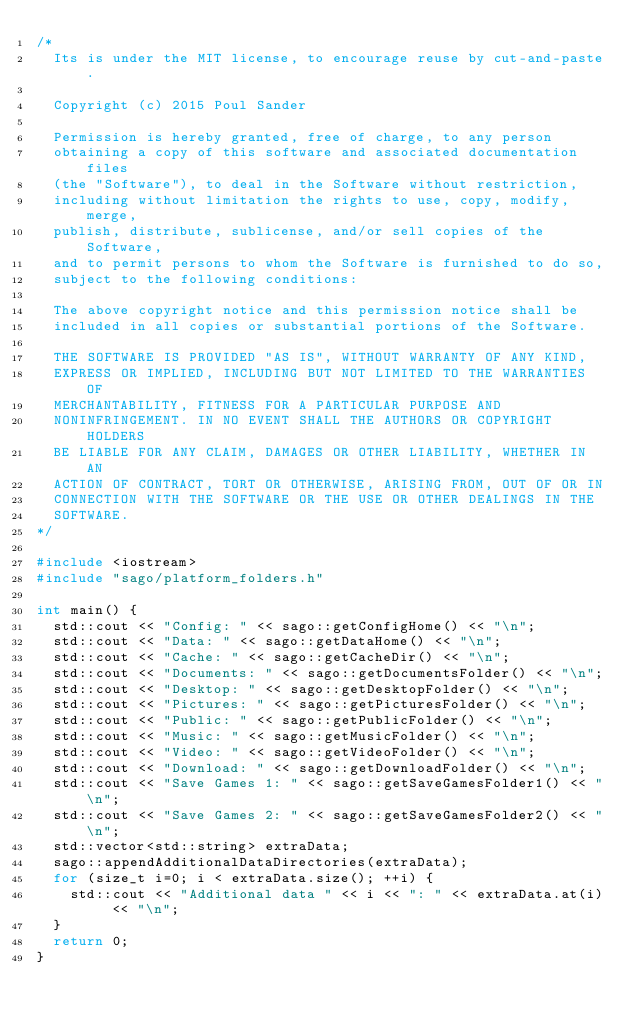Convert code to text. <code><loc_0><loc_0><loc_500><loc_500><_C++_>/*
  Its is under the MIT license, to encourage reuse by cut-and-paste.

  Copyright (c) 2015 Poul Sander

  Permission is hereby granted, free of charge, to any person
  obtaining a copy of this software and associated documentation files
  (the "Software"), to deal in the Software without restriction,
  including without limitation the rights to use, copy, modify, merge,
  publish, distribute, sublicense, and/or sell copies of the Software,
  and to permit persons to whom the Software is furnished to do so,
  subject to the following conditions:

  The above copyright notice and this permission notice shall be
  included in all copies or substantial portions of the Software.

  THE SOFTWARE IS PROVIDED "AS IS", WITHOUT WARRANTY OF ANY KIND,
  EXPRESS OR IMPLIED, INCLUDING BUT NOT LIMITED TO THE WARRANTIES OF
  MERCHANTABILITY, FITNESS FOR A PARTICULAR PURPOSE AND
  NONINFRINGEMENT. IN NO EVENT SHALL THE AUTHORS OR COPYRIGHT HOLDERS
  BE LIABLE FOR ANY CLAIM, DAMAGES OR OTHER LIABILITY, WHETHER IN AN
  ACTION OF CONTRACT, TORT OR OTHERWISE, ARISING FROM, OUT OF OR IN
  CONNECTION WITH THE SOFTWARE OR THE USE OR OTHER DEALINGS IN THE
  SOFTWARE.
*/

#include <iostream>
#include "sago/platform_folders.h"

int main() {
	std::cout << "Config: " << sago::getConfigHome() << "\n";
	std::cout << "Data: " << sago::getDataHome() << "\n";
	std::cout << "Cache: " << sago::getCacheDir() << "\n";
	std::cout << "Documents: " << sago::getDocumentsFolder() << "\n";
	std::cout << "Desktop: " << sago::getDesktopFolder() << "\n";
	std::cout << "Pictures: " << sago::getPicturesFolder() << "\n";
	std::cout << "Public: " << sago::getPublicFolder() << "\n";
	std::cout << "Music: " << sago::getMusicFolder() << "\n";
	std::cout << "Video: " << sago::getVideoFolder() << "\n";
	std::cout << "Download: " << sago::getDownloadFolder() << "\n";
	std::cout << "Save Games 1: " << sago::getSaveGamesFolder1() << "\n";
	std::cout << "Save Games 2: " << sago::getSaveGamesFolder2() << "\n";
	std::vector<std::string> extraData;
	sago::appendAdditionalDataDirectories(extraData);
	for (size_t i=0; i < extraData.size(); ++i) {
		std::cout << "Additional data " << i << ": " << extraData.at(i) << "\n";
	}
	return 0;
}
</code> 